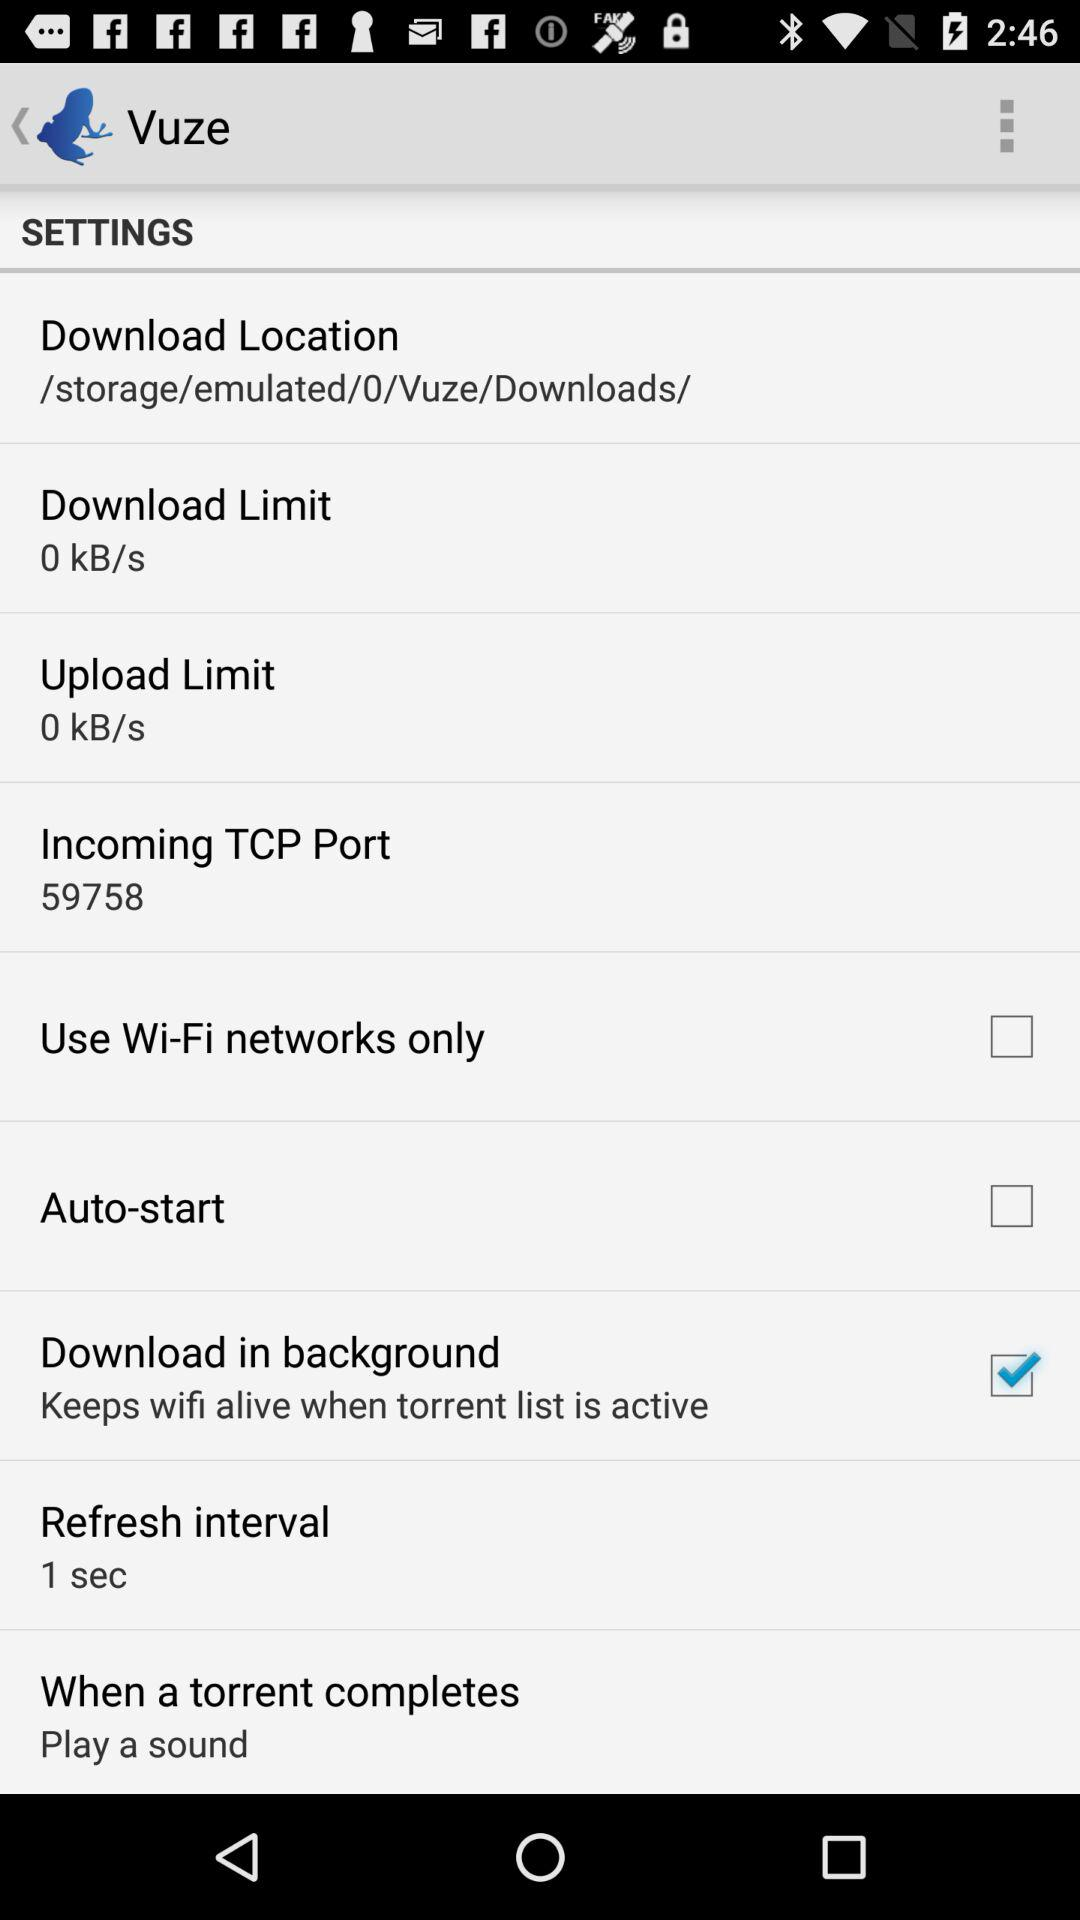What is the refresh interval? The refresh interval is 1 second. 